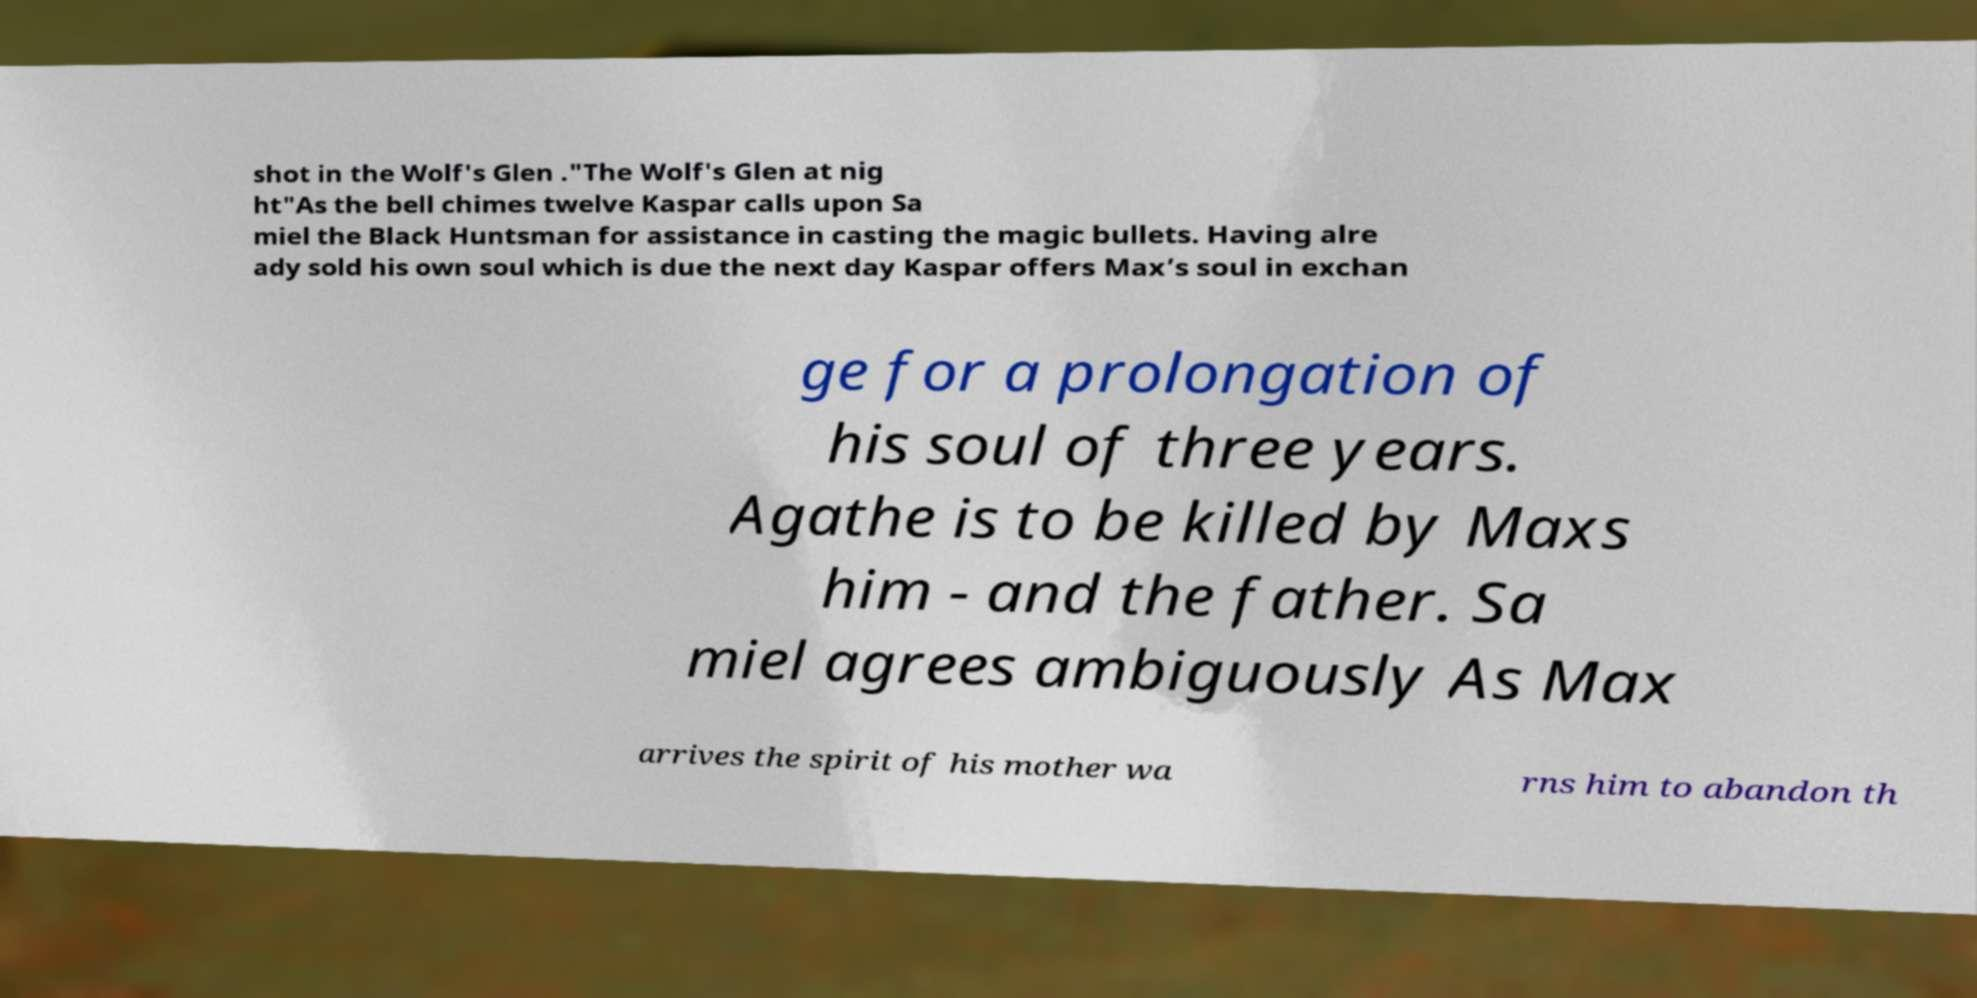What messages or text are displayed in this image? I need them in a readable, typed format. shot in the Wolf's Glen ."The Wolf's Glen at nig ht"As the bell chimes twelve Kaspar calls upon Sa miel the Black Huntsman for assistance in casting the magic bullets. Having alre ady sold his own soul which is due the next day Kaspar offers Max’s soul in exchan ge for a prolongation of his soul of three years. Agathe is to be killed by Maxs him - and the father. Sa miel agrees ambiguously As Max arrives the spirit of his mother wa rns him to abandon th 